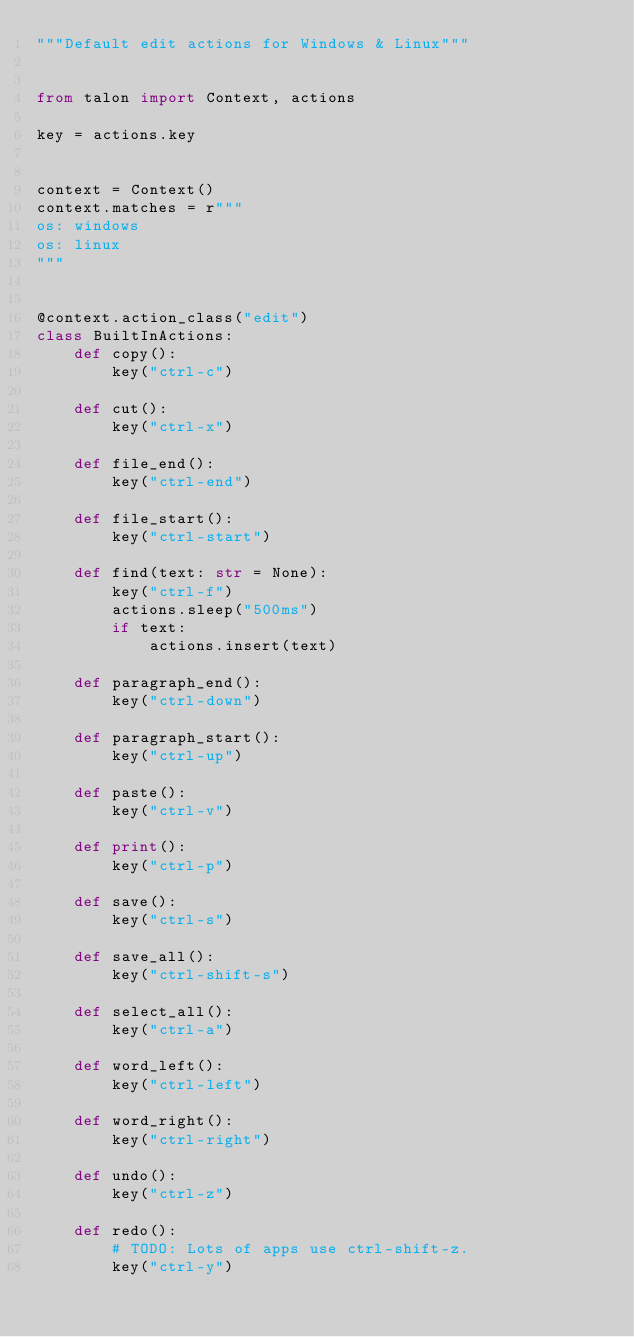<code> <loc_0><loc_0><loc_500><loc_500><_Python_>"""Default edit actions for Windows & Linux"""


from talon import Context, actions

key = actions.key


context = Context()
context.matches = r"""
os: windows
os: linux
"""


@context.action_class("edit")
class BuiltInActions:
    def copy():
        key("ctrl-c")

    def cut():
        key("ctrl-x")

    def file_end():
        key("ctrl-end")

    def file_start():
        key("ctrl-start")

    def find(text: str = None):
        key("ctrl-f")
        actions.sleep("500ms")
        if text:
            actions.insert(text)

    def paragraph_end():
        key("ctrl-down")

    def paragraph_start():
        key("ctrl-up")

    def paste():
        key("ctrl-v")

    def print():
        key("ctrl-p")

    def save():
        key("ctrl-s")

    def save_all():
        key("ctrl-shift-s")

    def select_all():
        key("ctrl-a")

    def word_left():
        key("ctrl-left")

    def word_right():
        key("ctrl-right")

    def undo():
        key("ctrl-z")

    def redo():
        # TODO: Lots of apps use ctrl-shift-z.
        key("ctrl-y")
</code> 